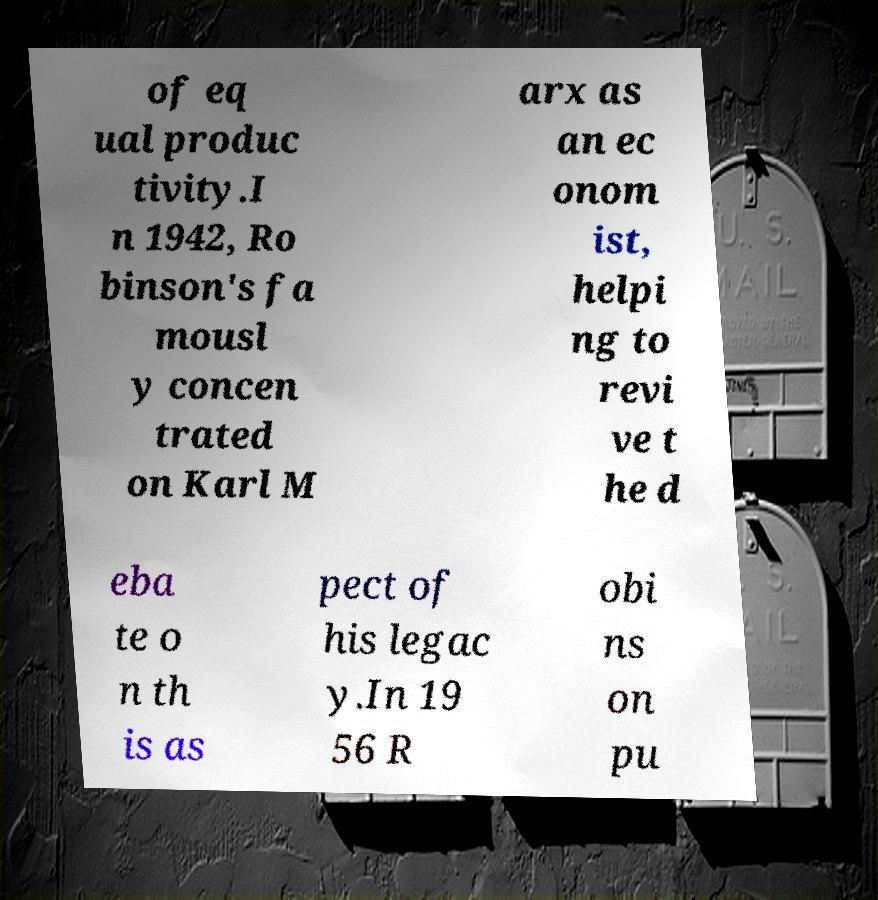What messages or text are displayed in this image? I need them in a readable, typed format. of eq ual produc tivity.I n 1942, Ro binson's fa mousl y concen trated on Karl M arx as an ec onom ist, helpi ng to revi ve t he d eba te o n th is as pect of his legac y.In 19 56 R obi ns on pu 